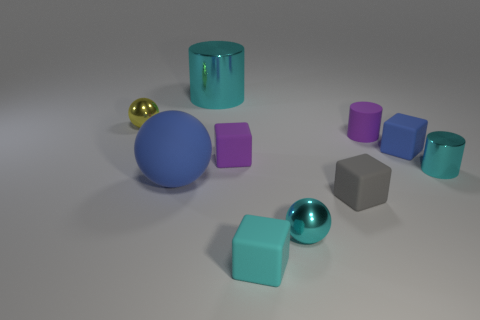What is the cyan cylinder in front of the cyan shiny object that is behind the purple object that is in front of the blue block made of?
Offer a terse response. Metal. How many matte things are large cyan cylinders or purple things?
Provide a succinct answer. 2. Are there any big green metallic things?
Keep it short and to the point. No. There is a metallic cylinder that is on the left side of the cyan metal cylinder that is to the right of the large cylinder; what is its color?
Provide a short and direct response. Cyan. How many other objects are there of the same color as the big ball?
Your response must be concise. 1. What number of things are either tiny cyan shiny cylinders or small shiny balls that are left of the large cylinder?
Offer a very short reply. 2. There is a sphere in front of the blue ball; what color is it?
Offer a very short reply. Cyan. The yellow metallic thing has what shape?
Your answer should be compact. Sphere. There is a big object that is in front of the metallic cylinder that is on the right side of the purple cylinder; what is its material?
Give a very brief answer. Rubber. How many other objects are the same material as the gray block?
Keep it short and to the point. 5. 